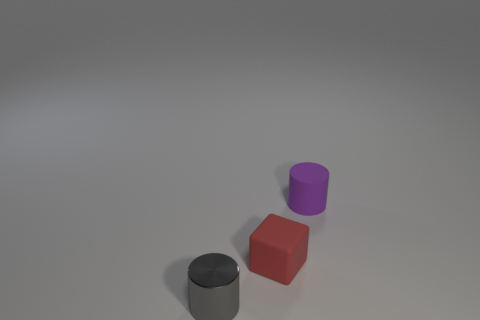Add 1 tiny gray rubber cylinders. How many objects exist? 4 Subtract all blocks. How many objects are left? 2 Add 2 gray shiny objects. How many gray shiny objects are left? 3 Add 3 big blocks. How many big blocks exist? 3 Subtract 0 green spheres. How many objects are left? 3 Subtract all large purple rubber spheres. Subtract all purple rubber objects. How many objects are left? 2 